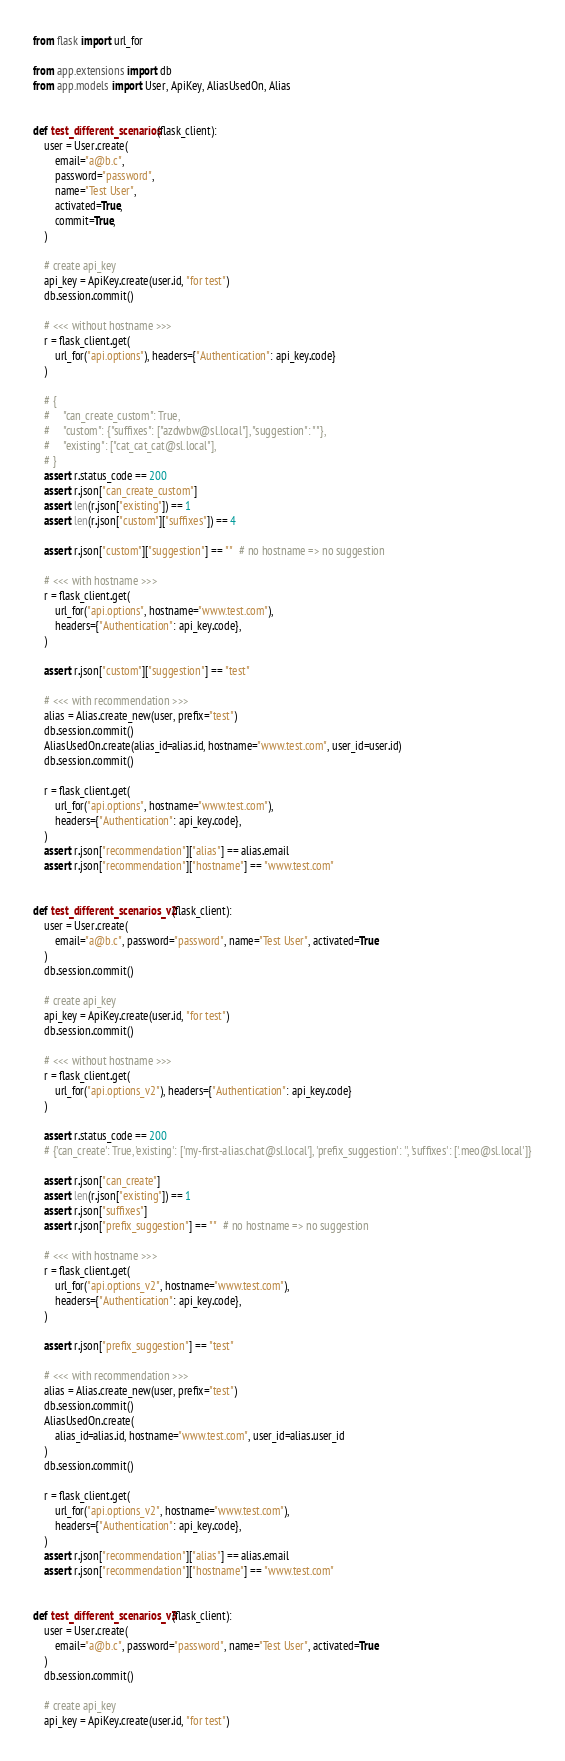Convert code to text. <code><loc_0><loc_0><loc_500><loc_500><_Python_>from flask import url_for

from app.extensions import db
from app.models import User, ApiKey, AliasUsedOn, Alias


def test_different_scenarios(flask_client):
    user = User.create(
        email="a@b.c",
        password="password",
        name="Test User",
        activated=True,
        commit=True,
    )

    # create api_key
    api_key = ApiKey.create(user.id, "for test")
    db.session.commit()

    # <<< without hostname >>>
    r = flask_client.get(
        url_for("api.options"), headers={"Authentication": api_key.code}
    )

    # {
    #     "can_create_custom": True,
    #     "custom": {"suffixes": ["azdwbw@sl.local"], "suggestion": ""},
    #     "existing": ["cat_cat_cat@sl.local"],
    # }
    assert r.status_code == 200
    assert r.json["can_create_custom"]
    assert len(r.json["existing"]) == 1
    assert len(r.json["custom"]["suffixes"]) == 4

    assert r.json["custom"]["suggestion"] == ""  # no hostname => no suggestion

    # <<< with hostname >>>
    r = flask_client.get(
        url_for("api.options", hostname="www.test.com"),
        headers={"Authentication": api_key.code},
    )

    assert r.json["custom"]["suggestion"] == "test"

    # <<< with recommendation >>>
    alias = Alias.create_new(user, prefix="test")
    db.session.commit()
    AliasUsedOn.create(alias_id=alias.id, hostname="www.test.com", user_id=user.id)
    db.session.commit()

    r = flask_client.get(
        url_for("api.options", hostname="www.test.com"),
        headers={"Authentication": api_key.code},
    )
    assert r.json["recommendation"]["alias"] == alias.email
    assert r.json["recommendation"]["hostname"] == "www.test.com"


def test_different_scenarios_v2(flask_client):
    user = User.create(
        email="a@b.c", password="password", name="Test User", activated=True
    )
    db.session.commit()

    # create api_key
    api_key = ApiKey.create(user.id, "for test")
    db.session.commit()

    # <<< without hostname >>>
    r = flask_client.get(
        url_for("api.options_v2"), headers={"Authentication": api_key.code}
    )

    assert r.status_code == 200
    # {'can_create': True, 'existing': ['my-first-alias.chat@sl.local'], 'prefix_suggestion': '', 'suffixes': ['.meo@sl.local']}

    assert r.json["can_create"]
    assert len(r.json["existing"]) == 1
    assert r.json["suffixes"]
    assert r.json["prefix_suggestion"] == ""  # no hostname => no suggestion

    # <<< with hostname >>>
    r = flask_client.get(
        url_for("api.options_v2", hostname="www.test.com"),
        headers={"Authentication": api_key.code},
    )

    assert r.json["prefix_suggestion"] == "test"

    # <<< with recommendation >>>
    alias = Alias.create_new(user, prefix="test")
    db.session.commit()
    AliasUsedOn.create(
        alias_id=alias.id, hostname="www.test.com", user_id=alias.user_id
    )
    db.session.commit()

    r = flask_client.get(
        url_for("api.options_v2", hostname="www.test.com"),
        headers={"Authentication": api_key.code},
    )
    assert r.json["recommendation"]["alias"] == alias.email
    assert r.json["recommendation"]["hostname"] == "www.test.com"


def test_different_scenarios_v3(flask_client):
    user = User.create(
        email="a@b.c", password="password", name="Test User", activated=True
    )
    db.session.commit()

    # create api_key
    api_key = ApiKey.create(user.id, "for test")</code> 